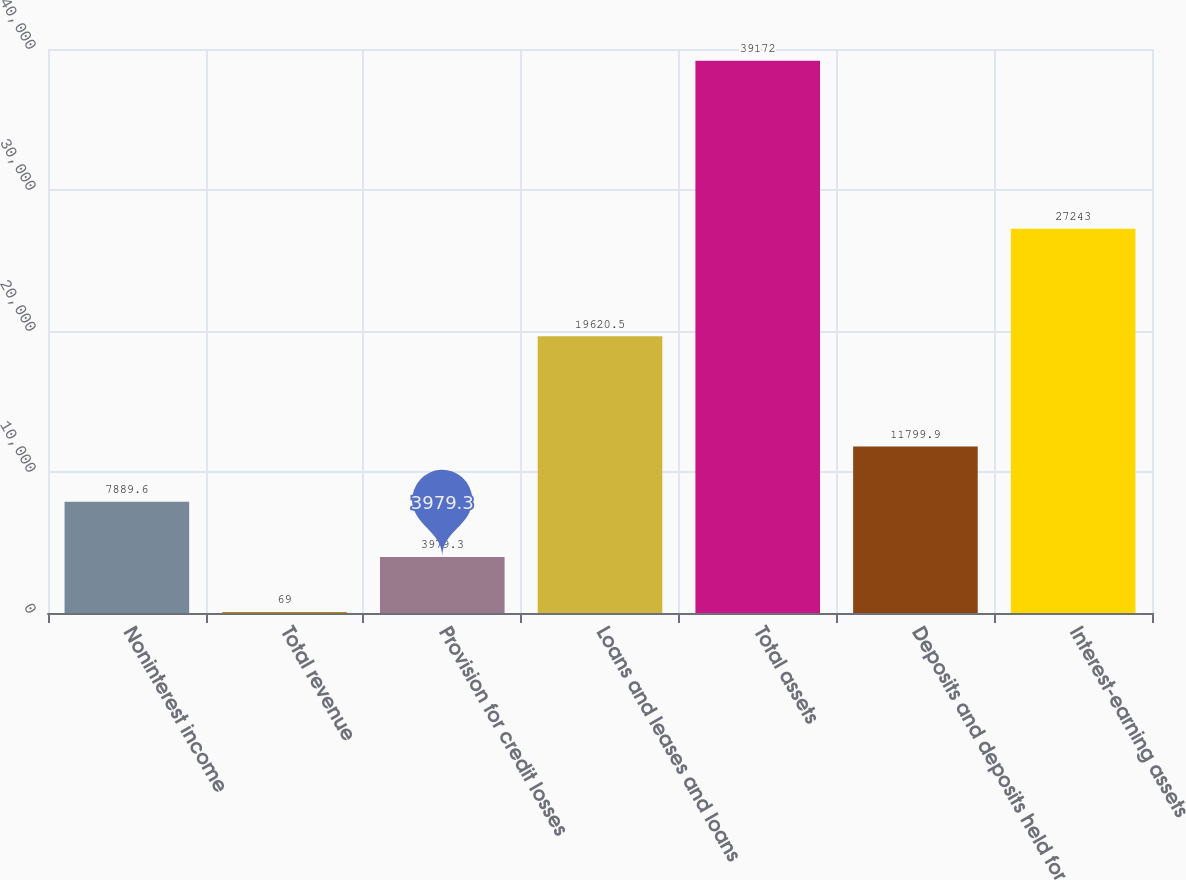Convert chart to OTSL. <chart><loc_0><loc_0><loc_500><loc_500><bar_chart><fcel>Noninterest income<fcel>Total revenue<fcel>Provision for credit losses<fcel>Loans and leases and loans<fcel>Total assets<fcel>Deposits and deposits held for<fcel>Interest-earning assets<nl><fcel>7889.6<fcel>69<fcel>3979.3<fcel>19620.5<fcel>39172<fcel>11799.9<fcel>27243<nl></chart> 